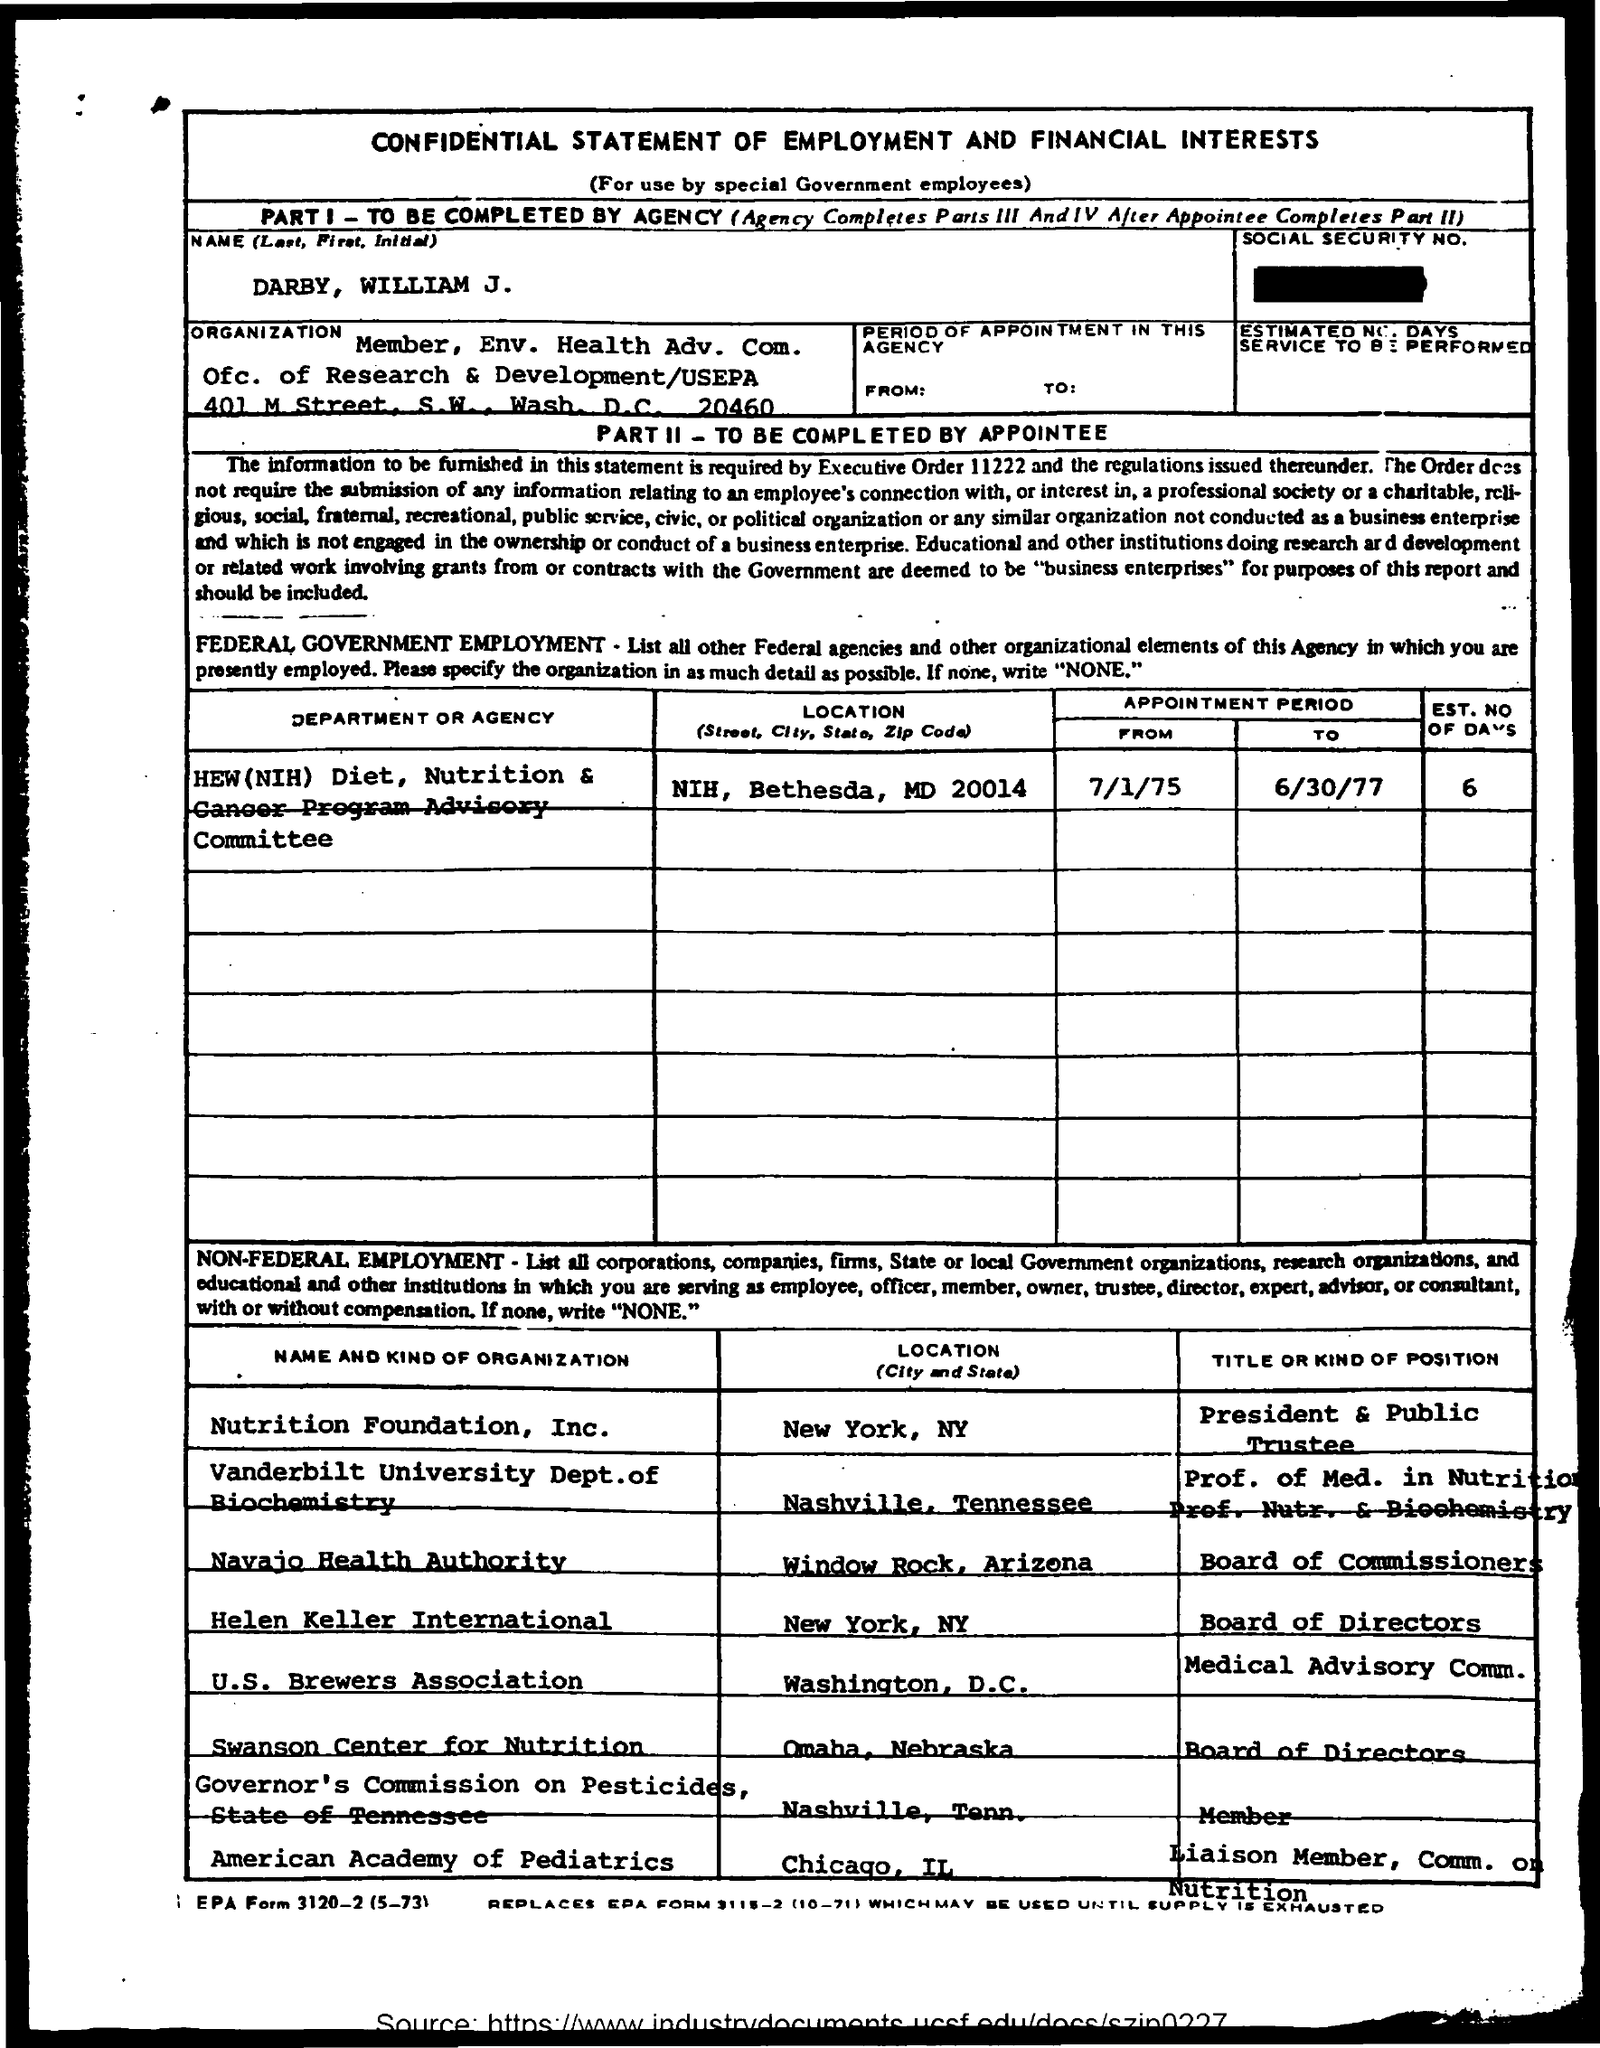Highlight a few significant elements in this photo. The name "William J. Darby" is mentioned. The location of the American Academy of Pediatrics is Chicago, Illinois. The HEW(NIH) diet requires a mention of the 'est. no of days' for optimal results, with a recommended range of 6 to... The U.S. Brewers Association is located in Washington, D.C. I would like to acknowledge the location of "Nutrition Foundation, Inc." in New York, NY. 